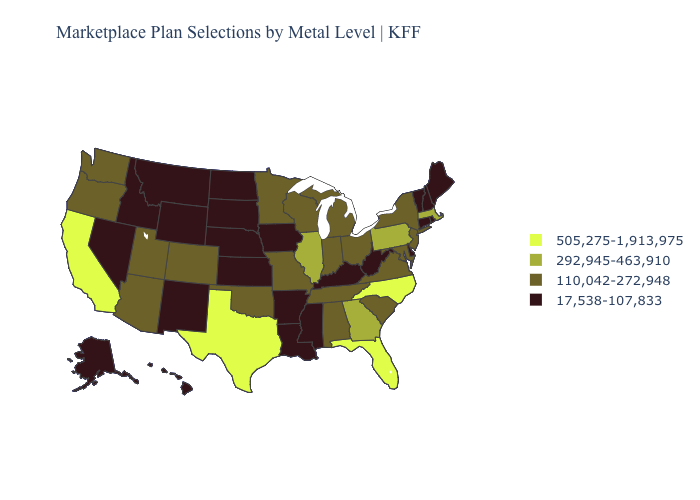Does Michigan have a lower value than Pennsylvania?
Give a very brief answer. Yes. What is the value of Delaware?
Be succinct. 17,538-107,833. Does Virginia have the highest value in the USA?
Write a very short answer. No. Does the map have missing data?
Concise answer only. No. Name the states that have a value in the range 110,042-272,948?
Short answer required. Alabama, Arizona, Colorado, Indiana, Maryland, Michigan, Minnesota, Missouri, New Jersey, New York, Ohio, Oklahoma, Oregon, South Carolina, Tennessee, Utah, Virginia, Washington, Wisconsin. Which states have the highest value in the USA?
Quick response, please. California, Florida, North Carolina, Texas. What is the value of Wyoming?
Be succinct. 17,538-107,833. What is the lowest value in the West?
Concise answer only. 17,538-107,833. Name the states that have a value in the range 110,042-272,948?
Short answer required. Alabama, Arizona, Colorado, Indiana, Maryland, Michigan, Minnesota, Missouri, New Jersey, New York, Ohio, Oklahoma, Oregon, South Carolina, Tennessee, Utah, Virginia, Washington, Wisconsin. Does the map have missing data?
Write a very short answer. No. Name the states that have a value in the range 110,042-272,948?
Short answer required. Alabama, Arizona, Colorado, Indiana, Maryland, Michigan, Minnesota, Missouri, New Jersey, New York, Ohio, Oklahoma, Oregon, South Carolina, Tennessee, Utah, Virginia, Washington, Wisconsin. What is the lowest value in the USA?
Short answer required. 17,538-107,833. Is the legend a continuous bar?
Short answer required. No. Does Arizona have the same value as Utah?
Keep it brief. Yes. What is the value of North Dakota?
Write a very short answer. 17,538-107,833. 